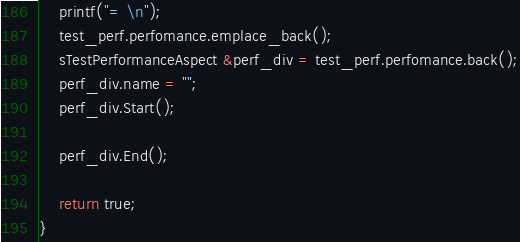<code> <loc_0><loc_0><loc_500><loc_500><_C++_>	printf("= \n");
	test_perf.perfomance.emplace_back();
	sTestPerformanceAspect &perf_div = test_perf.perfomance.back();
	perf_div.name = "";
	perf_div.Start();

	perf_div.End();

	return true;
}
</code> 